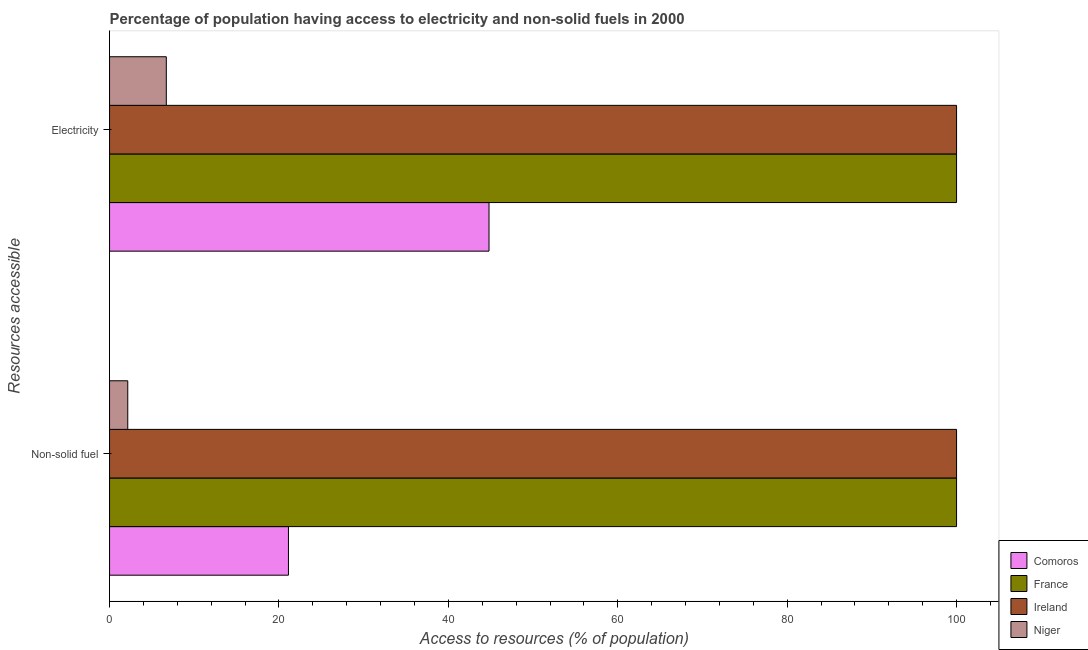How many groups of bars are there?
Provide a short and direct response. 2. Are the number of bars per tick equal to the number of legend labels?
Make the answer very short. Yes. How many bars are there on the 2nd tick from the bottom?
Provide a succinct answer. 4. What is the label of the 1st group of bars from the top?
Provide a short and direct response. Electricity. What is the percentage of population having access to non-solid fuel in Niger?
Your response must be concise. 2.15. In which country was the percentage of population having access to electricity minimum?
Make the answer very short. Niger. What is the total percentage of population having access to non-solid fuel in the graph?
Provide a succinct answer. 223.27. What is the difference between the percentage of population having access to electricity in Niger and that in Ireland?
Offer a very short reply. -93.3. What is the difference between the percentage of population having access to electricity in France and the percentage of population having access to non-solid fuel in Niger?
Provide a short and direct response. 97.85. What is the average percentage of population having access to electricity per country?
Keep it short and to the point. 62.88. In how many countries, is the percentage of population having access to non-solid fuel greater than 60 %?
Give a very brief answer. 2. What is the ratio of the percentage of population having access to electricity in France to that in Niger?
Offer a terse response. 14.93. Is the percentage of population having access to electricity in France less than that in Niger?
Ensure brevity in your answer.  No. What does the 4th bar from the top in Electricity represents?
Make the answer very short. Comoros. What does the 1st bar from the bottom in Non-solid fuel represents?
Keep it short and to the point. Comoros. How many countries are there in the graph?
Your answer should be very brief. 4. Where does the legend appear in the graph?
Your answer should be very brief. Bottom right. How many legend labels are there?
Make the answer very short. 4. How are the legend labels stacked?
Your response must be concise. Vertical. What is the title of the graph?
Offer a terse response. Percentage of population having access to electricity and non-solid fuels in 2000. What is the label or title of the X-axis?
Provide a short and direct response. Access to resources (% of population). What is the label or title of the Y-axis?
Provide a succinct answer. Resources accessible. What is the Access to resources (% of population) in Comoros in Non-solid fuel?
Ensure brevity in your answer.  21.12. What is the Access to resources (% of population) of Niger in Non-solid fuel?
Provide a short and direct response. 2.15. What is the Access to resources (% of population) in Comoros in Electricity?
Ensure brevity in your answer.  44.8. What is the Access to resources (% of population) in France in Electricity?
Keep it short and to the point. 100. What is the Access to resources (% of population) of Niger in Electricity?
Make the answer very short. 6.7. Across all Resources accessible, what is the maximum Access to resources (% of population) of Comoros?
Provide a short and direct response. 44.8. Across all Resources accessible, what is the minimum Access to resources (% of population) in Comoros?
Offer a very short reply. 21.12. Across all Resources accessible, what is the minimum Access to resources (% of population) in Ireland?
Provide a succinct answer. 100. Across all Resources accessible, what is the minimum Access to resources (% of population) in Niger?
Your response must be concise. 2.15. What is the total Access to resources (% of population) of Comoros in the graph?
Provide a short and direct response. 65.92. What is the total Access to resources (% of population) in France in the graph?
Ensure brevity in your answer.  200. What is the total Access to resources (% of population) in Niger in the graph?
Offer a very short reply. 8.85. What is the difference between the Access to resources (% of population) of Comoros in Non-solid fuel and that in Electricity?
Provide a succinct answer. -23.68. What is the difference between the Access to resources (% of population) of France in Non-solid fuel and that in Electricity?
Your response must be concise. 0. What is the difference between the Access to resources (% of population) of Niger in Non-solid fuel and that in Electricity?
Your response must be concise. -4.55. What is the difference between the Access to resources (% of population) in Comoros in Non-solid fuel and the Access to resources (% of population) in France in Electricity?
Provide a short and direct response. -78.88. What is the difference between the Access to resources (% of population) of Comoros in Non-solid fuel and the Access to resources (% of population) of Ireland in Electricity?
Provide a succinct answer. -78.88. What is the difference between the Access to resources (% of population) in Comoros in Non-solid fuel and the Access to resources (% of population) in Niger in Electricity?
Offer a terse response. 14.42. What is the difference between the Access to resources (% of population) in France in Non-solid fuel and the Access to resources (% of population) in Niger in Electricity?
Your answer should be very brief. 93.3. What is the difference between the Access to resources (% of population) of Ireland in Non-solid fuel and the Access to resources (% of population) of Niger in Electricity?
Your answer should be compact. 93.3. What is the average Access to resources (% of population) of Comoros per Resources accessible?
Offer a terse response. 32.96. What is the average Access to resources (% of population) in France per Resources accessible?
Ensure brevity in your answer.  100. What is the average Access to resources (% of population) of Niger per Resources accessible?
Your answer should be very brief. 4.42. What is the difference between the Access to resources (% of population) of Comoros and Access to resources (% of population) of France in Non-solid fuel?
Provide a succinct answer. -78.88. What is the difference between the Access to resources (% of population) of Comoros and Access to resources (% of population) of Ireland in Non-solid fuel?
Keep it short and to the point. -78.88. What is the difference between the Access to resources (% of population) of Comoros and Access to resources (% of population) of Niger in Non-solid fuel?
Ensure brevity in your answer.  18.97. What is the difference between the Access to resources (% of population) in France and Access to resources (% of population) in Niger in Non-solid fuel?
Your answer should be compact. 97.85. What is the difference between the Access to resources (% of population) in Ireland and Access to resources (% of population) in Niger in Non-solid fuel?
Ensure brevity in your answer.  97.85. What is the difference between the Access to resources (% of population) in Comoros and Access to resources (% of population) in France in Electricity?
Give a very brief answer. -55.2. What is the difference between the Access to resources (% of population) of Comoros and Access to resources (% of population) of Ireland in Electricity?
Make the answer very short. -55.2. What is the difference between the Access to resources (% of population) of Comoros and Access to resources (% of population) of Niger in Electricity?
Ensure brevity in your answer.  38.1. What is the difference between the Access to resources (% of population) in France and Access to resources (% of population) in Niger in Electricity?
Ensure brevity in your answer.  93.3. What is the difference between the Access to resources (% of population) in Ireland and Access to resources (% of population) in Niger in Electricity?
Provide a short and direct response. 93.3. What is the ratio of the Access to resources (% of population) in Comoros in Non-solid fuel to that in Electricity?
Your response must be concise. 0.47. What is the ratio of the Access to resources (% of population) of France in Non-solid fuel to that in Electricity?
Your answer should be compact. 1. What is the ratio of the Access to resources (% of population) of Ireland in Non-solid fuel to that in Electricity?
Give a very brief answer. 1. What is the ratio of the Access to resources (% of population) in Niger in Non-solid fuel to that in Electricity?
Keep it short and to the point. 0.32. What is the difference between the highest and the second highest Access to resources (% of population) of Comoros?
Make the answer very short. 23.68. What is the difference between the highest and the second highest Access to resources (% of population) in Ireland?
Make the answer very short. 0. What is the difference between the highest and the second highest Access to resources (% of population) in Niger?
Provide a succinct answer. 4.55. What is the difference between the highest and the lowest Access to resources (% of population) in Comoros?
Provide a succinct answer. 23.68. What is the difference between the highest and the lowest Access to resources (% of population) in Ireland?
Keep it short and to the point. 0. What is the difference between the highest and the lowest Access to resources (% of population) in Niger?
Provide a succinct answer. 4.55. 